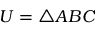<formula> <loc_0><loc_0><loc_500><loc_500>U = \triangle A B C</formula> 